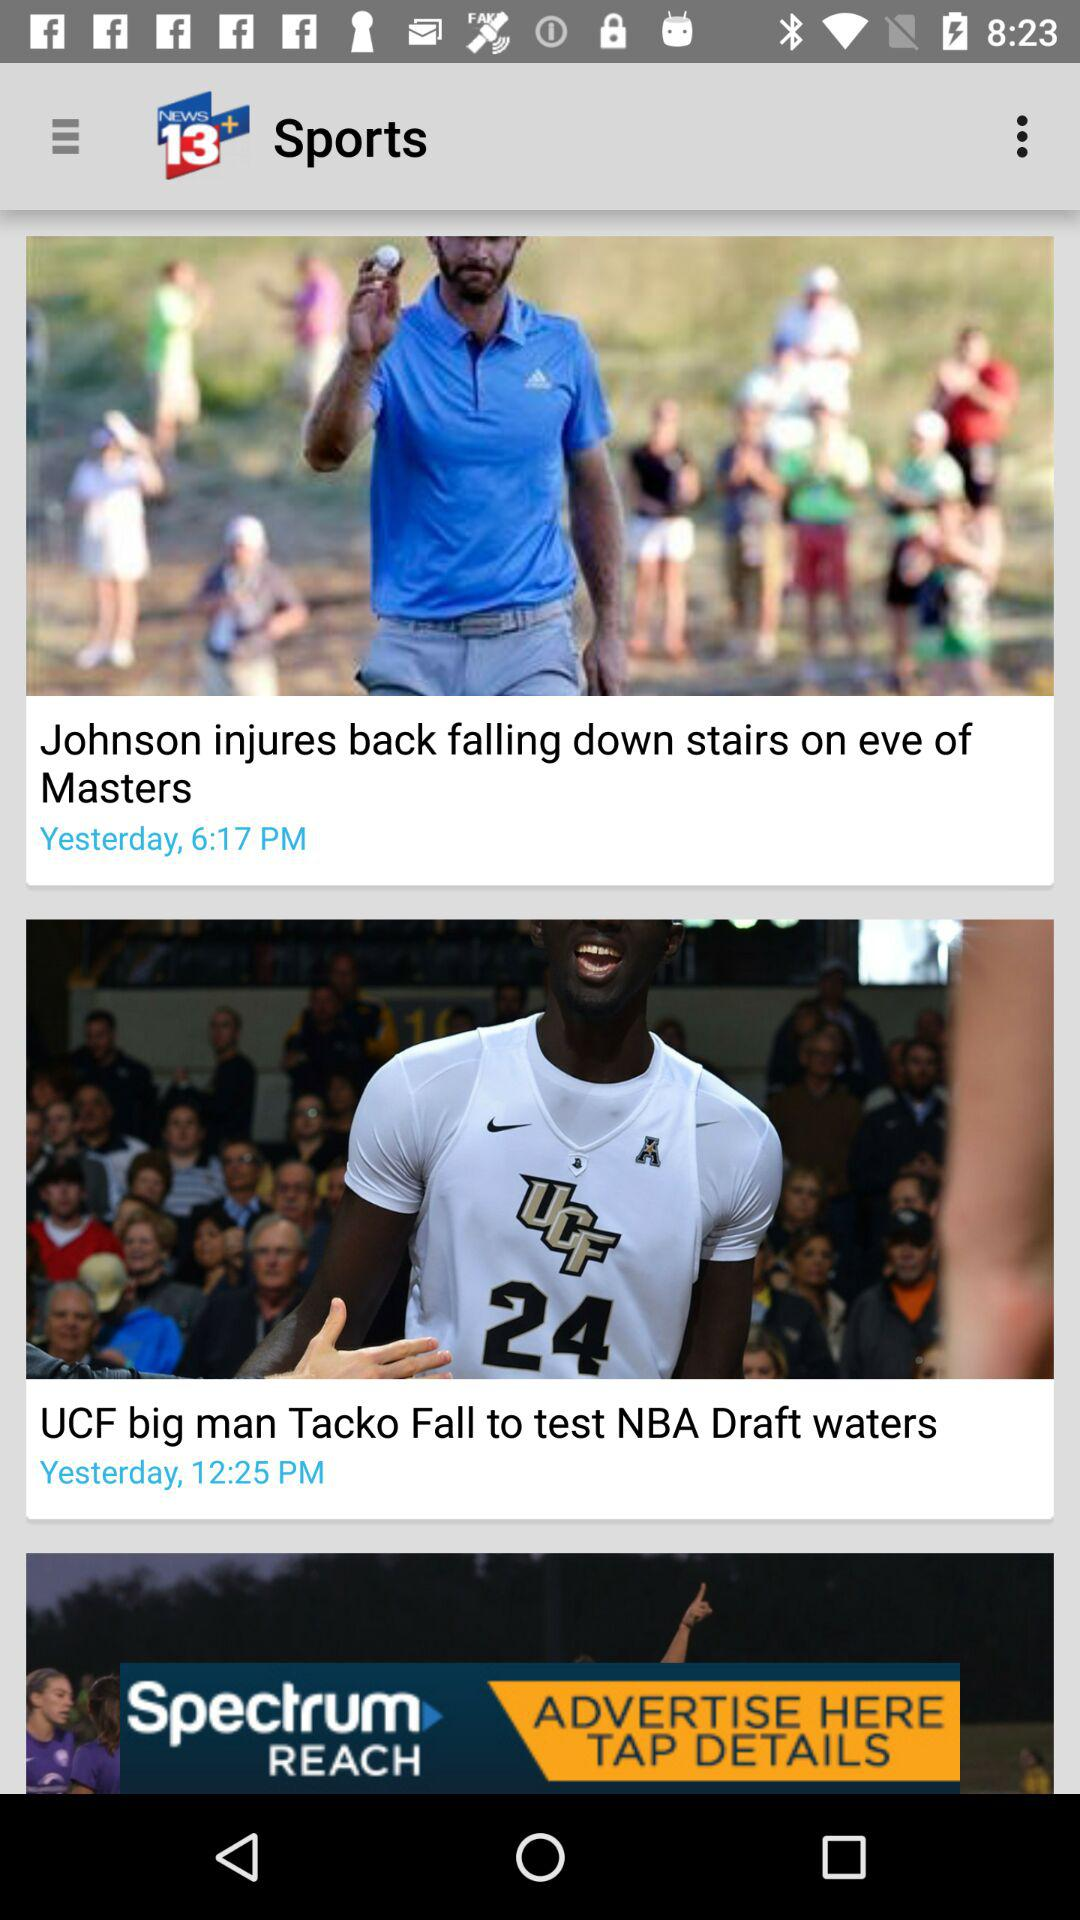At what time was the news about "Johnson injures back falling down stairs on eve of Masters" posted? The news was posted yesterday at 6:17 PM. 